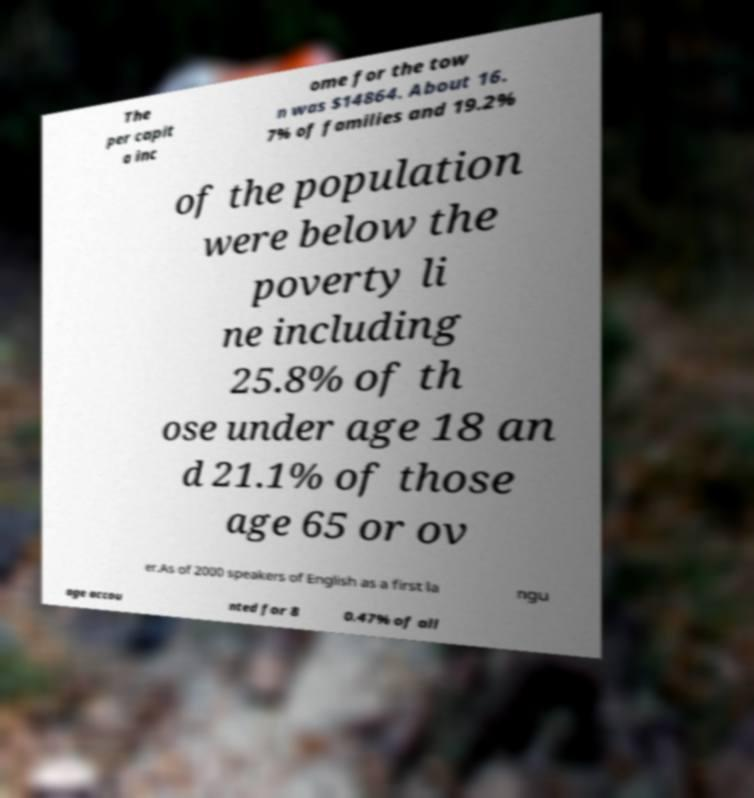Can you read and provide the text displayed in the image?This photo seems to have some interesting text. Can you extract and type it out for me? The per capit a inc ome for the tow n was $14864. About 16. 7% of families and 19.2% of the population were below the poverty li ne including 25.8% of th ose under age 18 an d 21.1% of those age 65 or ov er.As of 2000 speakers of English as a first la ngu age accou nted for 8 0.47% of all 